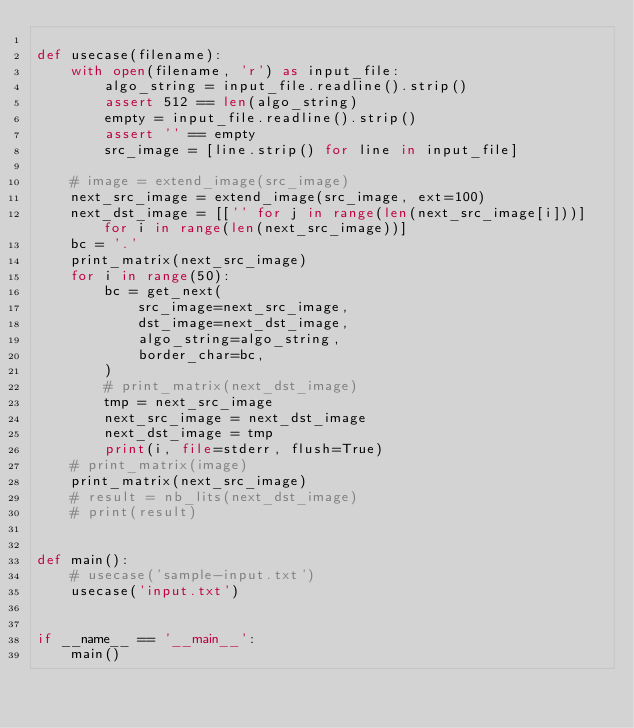<code> <loc_0><loc_0><loc_500><loc_500><_Python_>
def usecase(filename):
    with open(filename, 'r') as input_file:
        algo_string = input_file.readline().strip()
        assert 512 == len(algo_string)
        empty = input_file.readline().strip()
        assert '' == empty
        src_image = [line.strip() for line in input_file]

    # image = extend_image(src_image)
    next_src_image = extend_image(src_image, ext=100)
    next_dst_image = [['' for j in range(len(next_src_image[i]))] for i in range(len(next_src_image))]
    bc = '.'
    print_matrix(next_src_image)
    for i in range(50):
        bc = get_next(
            src_image=next_src_image,
            dst_image=next_dst_image,
            algo_string=algo_string,
            border_char=bc,
        )
        # print_matrix(next_dst_image)
        tmp = next_src_image
        next_src_image = next_dst_image
        next_dst_image = tmp
        print(i, file=stderr, flush=True)
    # print_matrix(image)
    print_matrix(next_src_image)
    # result = nb_lits(next_dst_image)
    # print(result)


def main():
    # usecase('sample-input.txt')
    usecase('input.txt')


if __name__ == '__main__':
    main()
</code> 